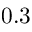Convert formula to latex. <formula><loc_0><loc_0><loc_500><loc_500>0 . 3</formula> 